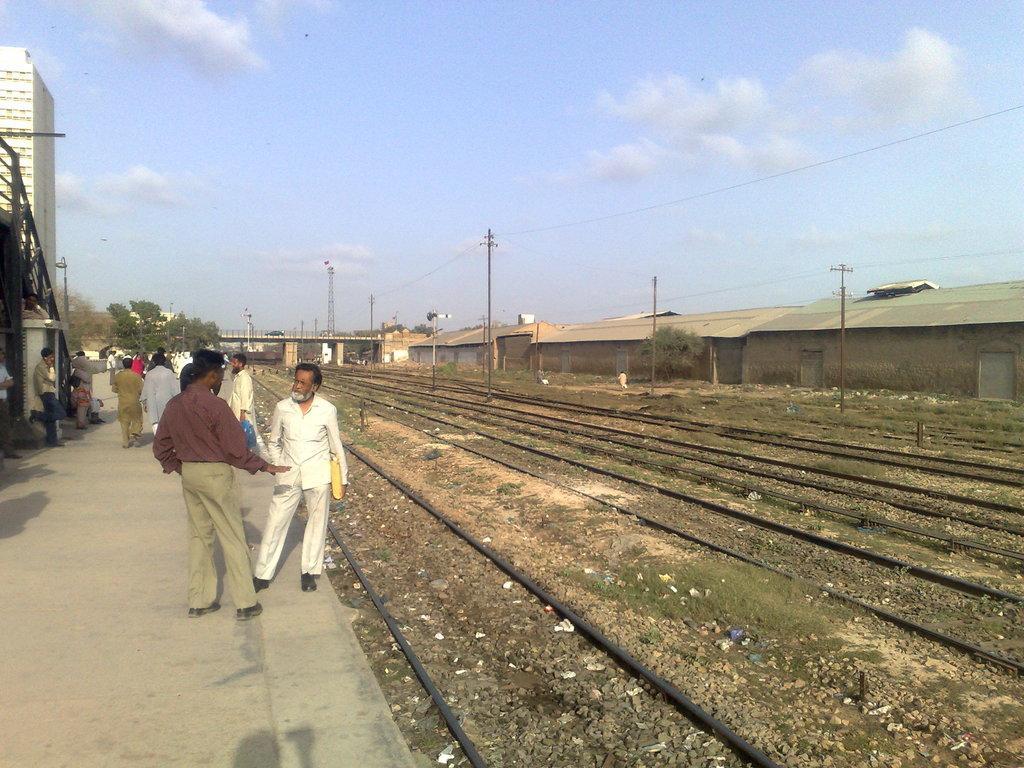Can you describe this image briefly? This is an outside view. On the right side there are some railway tracks on the ground and few poles. In the background there are few houses, tree and a bridge. At the top of the image I can see the sky and clouds. On the left side there are few people standing on the platform and also there is a building. 